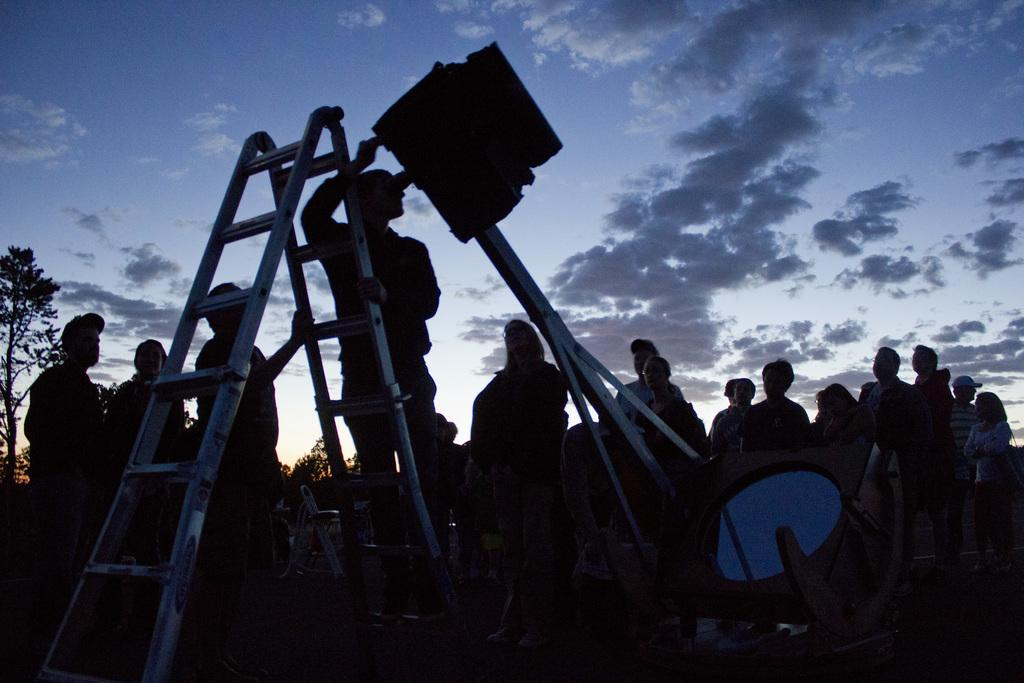Who or what can be seen in the image? There are people in the image. What object is present in the image that might be used for climbing or reaching high places? There is a ladder in the image. What can be seen in the distance in the image? There is sky and trees visible in the background of the image. What type of flock is visible in the image? There is no flock present in the image; it features people and a ladder. Is this a family gathering, as indicated by the people in the image? The image does not provide any information about the relationships between the people, so it cannot be determined if it is a family gathering. 